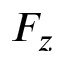Convert formula to latex. <formula><loc_0><loc_0><loc_500><loc_500>F _ { z }</formula> 